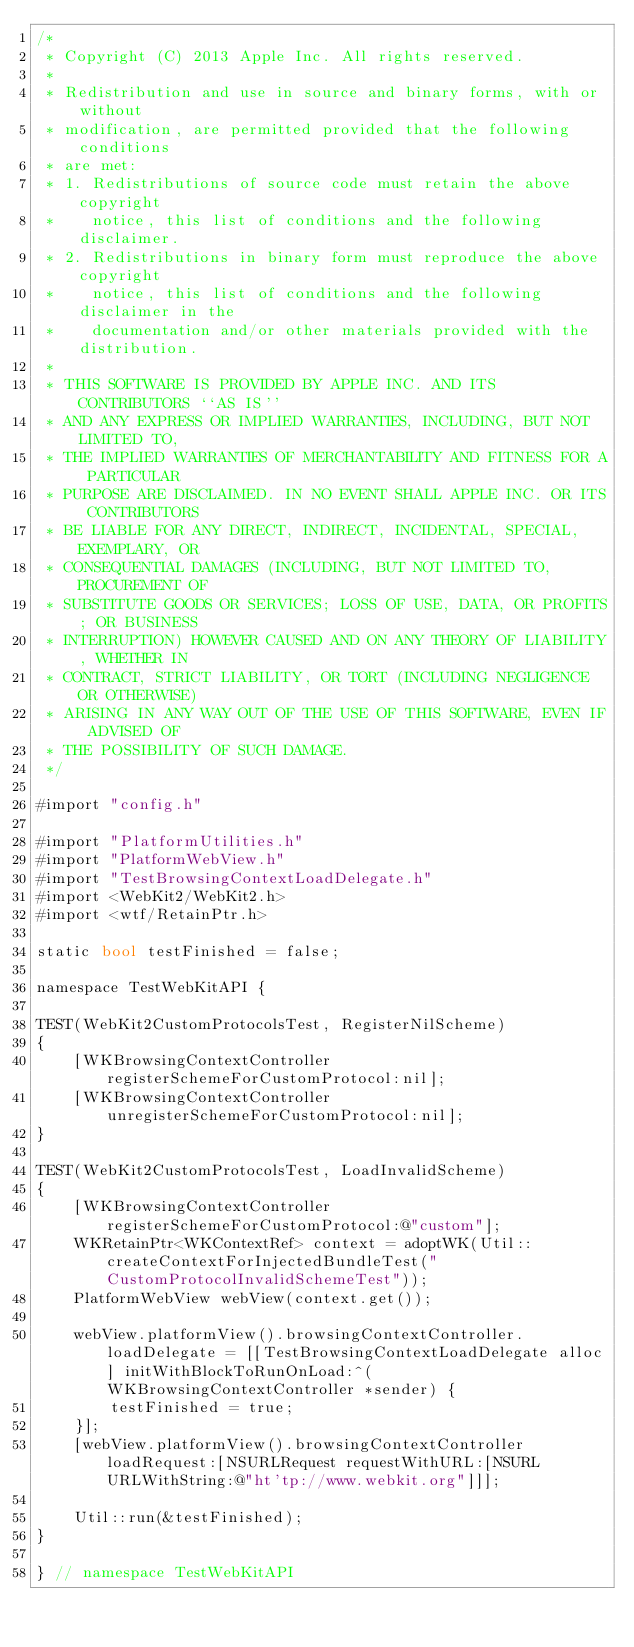<code> <loc_0><loc_0><loc_500><loc_500><_ObjectiveC_>/*
 * Copyright (C) 2013 Apple Inc. All rights reserved.
 *
 * Redistribution and use in source and binary forms, with or without
 * modification, are permitted provided that the following conditions
 * are met:
 * 1. Redistributions of source code must retain the above copyright
 *    notice, this list of conditions and the following disclaimer.
 * 2. Redistributions in binary form must reproduce the above copyright
 *    notice, this list of conditions and the following disclaimer in the
 *    documentation and/or other materials provided with the distribution.
 *
 * THIS SOFTWARE IS PROVIDED BY APPLE INC. AND ITS CONTRIBUTORS ``AS IS''
 * AND ANY EXPRESS OR IMPLIED WARRANTIES, INCLUDING, BUT NOT LIMITED TO,
 * THE IMPLIED WARRANTIES OF MERCHANTABILITY AND FITNESS FOR A PARTICULAR
 * PURPOSE ARE DISCLAIMED. IN NO EVENT SHALL APPLE INC. OR ITS CONTRIBUTORS
 * BE LIABLE FOR ANY DIRECT, INDIRECT, INCIDENTAL, SPECIAL, EXEMPLARY, OR
 * CONSEQUENTIAL DAMAGES (INCLUDING, BUT NOT LIMITED TO, PROCUREMENT OF
 * SUBSTITUTE GOODS OR SERVICES; LOSS OF USE, DATA, OR PROFITS; OR BUSINESS
 * INTERRUPTION) HOWEVER CAUSED AND ON ANY THEORY OF LIABILITY, WHETHER IN
 * CONTRACT, STRICT LIABILITY, OR TORT (INCLUDING NEGLIGENCE OR OTHERWISE)
 * ARISING IN ANY WAY OUT OF THE USE OF THIS SOFTWARE, EVEN IF ADVISED OF
 * THE POSSIBILITY OF SUCH DAMAGE.
 */

#import "config.h"

#import "PlatformUtilities.h"
#import "PlatformWebView.h"
#import "TestBrowsingContextLoadDelegate.h"
#import <WebKit2/WebKit2.h>
#import <wtf/RetainPtr.h>

static bool testFinished = false;

namespace TestWebKitAPI {

TEST(WebKit2CustomProtocolsTest, RegisterNilScheme)
{
    [WKBrowsingContextController registerSchemeForCustomProtocol:nil];
    [WKBrowsingContextController unregisterSchemeForCustomProtocol:nil];
}

TEST(WebKit2CustomProtocolsTest, LoadInvalidScheme)
{
    [WKBrowsingContextController registerSchemeForCustomProtocol:@"custom"];
    WKRetainPtr<WKContextRef> context = adoptWK(Util::createContextForInjectedBundleTest("CustomProtocolInvalidSchemeTest"));
    PlatformWebView webView(context.get());

    webView.platformView().browsingContextController.loadDelegate = [[TestBrowsingContextLoadDelegate alloc] initWithBlockToRunOnLoad:^(WKBrowsingContextController *sender) {
        testFinished = true;
    }];
    [webView.platformView().browsingContextController loadRequest:[NSURLRequest requestWithURL:[NSURL URLWithString:@"ht'tp://www.webkit.org"]]];
    
    Util::run(&testFinished);
}

} // namespace TestWebKitAPI
</code> 